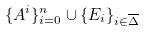<formula> <loc_0><loc_0><loc_500><loc_500>\{ A ^ { i } \} _ { i = 0 } ^ { n } \cup \{ E _ { i } \} _ { i \in \overline { \Delta } }</formula> 